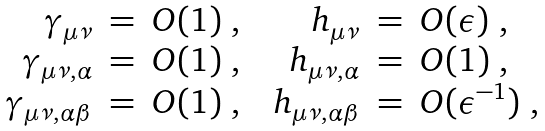Convert formula to latex. <formula><loc_0><loc_0><loc_500><loc_500>\begin{array} { r c l c r c l } \gamma _ { \mu \nu } & = & O ( 1 ) \ , & & h _ { \mu \nu } & = & O ( \epsilon ) \ , \\ \gamma _ { \mu \nu , \alpha } & = & O ( 1 ) \ , & & h _ { \mu \nu , \alpha } & = & O ( 1 ) \ , \\ \gamma _ { \mu \nu , \alpha \beta } & = & O ( 1 ) \ , & & h _ { \mu \nu , \alpha \beta } & = & O ( { \epsilon } ^ { - 1 } ) \ , \end{array}</formula> 